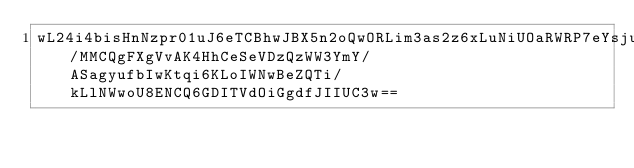<code> <loc_0><loc_0><loc_500><loc_500><_SML_>wL24i4bisHnNzpr01uJ6eTCBhwJBX5n2oQwORLim3as2z6xLuNiUOaRWRP7eYsjuoI8tlzv6FPGL65OtuPmUwWvQopLmK3FT2I8DuyWrMExMn4JB/MMCQgFXgVvAK4HhCeSeVDzQzWW3YmY/ASagyufbIwKtqi6KLoIWNwBeZQTi/kLlNWwoU8ENCQ6GDITVdOiGgdfJIIUC3w==</code> 